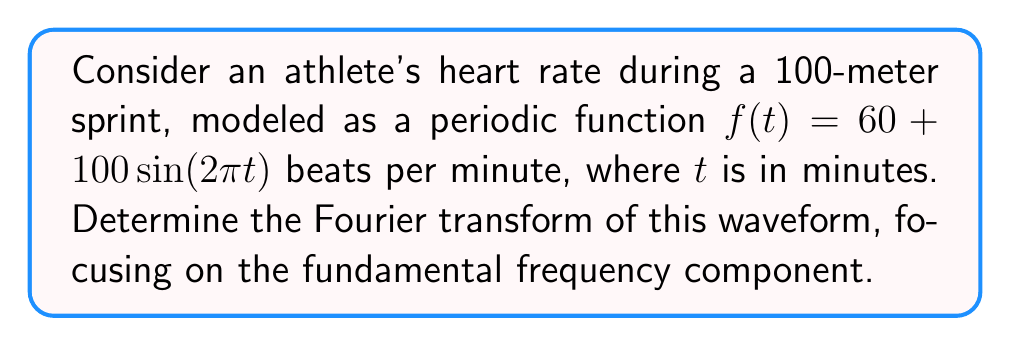Provide a solution to this math problem. To find the Fourier transform of the given waveform, we'll follow these steps:

1) The general form of the Fourier transform is:

   $$F(\omega) = \int_{-\infty}^{\infty} f(t) e^{-i\omega t} dt$$

2) Our function is $f(t) = 60 + 100\sin(2\pi t)$. We can split this into two parts:
   
   a) Constant term: $60$
   b) Sinusoidal term: $100\sin(2\pi t)$

3) The Fourier transform of a constant $A$ is $2\pi A\delta(\omega)$, where $\delta(\omega)$ is the Dirac delta function.

4) For the sinusoidal term, we use the property:

   $$\mathcal{F}\{A\sin(\omega_0 t)\} = \frac{iA\pi}{2}[\delta(\omega - \omega_0) - \delta(\omega + \omega_0)]$$

5) In our case, $A = 100$ and $\omega_0 = 2\pi$

6) Combining the results:

   $$F(\omega) = 120\pi\delta(\omega) + \frac{100\pi i}{2}[\delta(\omega - 2\pi) - \delta(\omega + 2\pi)]$$

7) The fundamental frequency component is at $\omega = 2\pi$, which corresponds to the athlete's heart rate fluctuation of once per minute.
Answer: $F(\omega) = 120\pi\delta(\omega) + 50\pi i[\delta(\omega - 2\pi) - \delta(\omega + 2\pi)]$ 